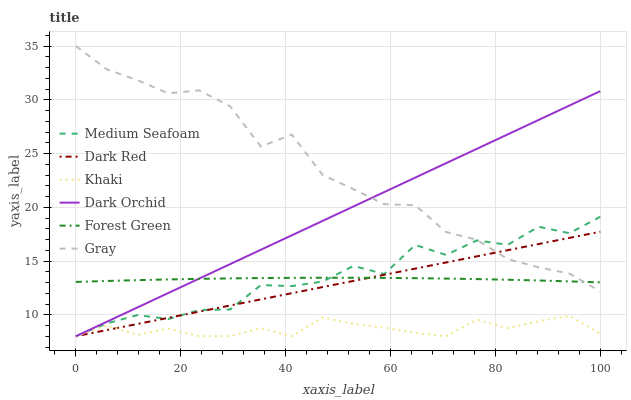Does Khaki have the minimum area under the curve?
Answer yes or no. Yes. Does Gray have the maximum area under the curve?
Answer yes or no. Yes. Does Dark Red have the minimum area under the curve?
Answer yes or no. No. Does Dark Red have the maximum area under the curve?
Answer yes or no. No. Is Dark Orchid the smoothest?
Answer yes or no. Yes. Is Medium Seafoam the roughest?
Answer yes or no. Yes. Is Khaki the smoothest?
Answer yes or no. No. Is Khaki the roughest?
Answer yes or no. No. Does Khaki have the lowest value?
Answer yes or no. Yes. Does Forest Green have the lowest value?
Answer yes or no. No. Does Gray have the highest value?
Answer yes or no. Yes. Does Dark Red have the highest value?
Answer yes or no. No. Is Khaki less than Gray?
Answer yes or no. Yes. Is Gray greater than Khaki?
Answer yes or no. Yes. Does Dark Red intersect Dark Orchid?
Answer yes or no. Yes. Is Dark Red less than Dark Orchid?
Answer yes or no. No. Is Dark Red greater than Dark Orchid?
Answer yes or no. No. Does Khaki intersect Gray?
Answer yes or no. No. 